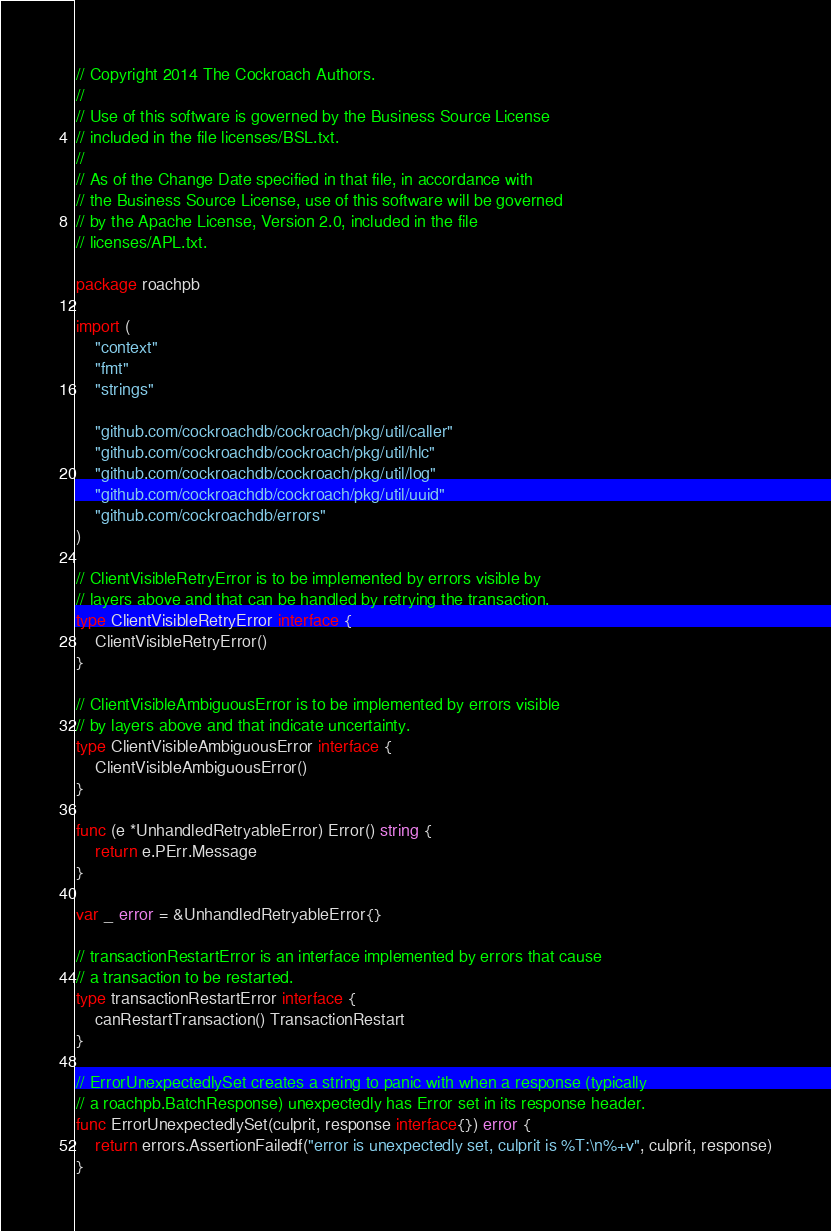<code> <loc_0><loc_0><loc_500><loc_500><_Go_>// Copyright 2014 The Cockroach Authors.
//
// Use of this software is governed by the Business Source License
// included in the file licenses/BSL.txt.
//
// As of the Change Date specified in that file, in accordance with
// the Business Source License, use of this software will be governed
// by the Apache License, Version 2.0, included in the file
// licenses/APL.txt.

package roachpb

import (
	"context"
	"fmt"
	"strings"

	"github.com/cockroachdb/cockroach/pkg/util/caller"
	"github.com/cockroachdb/cockroach/pkg/util/hlc"
	"github.com/cockroachdb/cockroach/pkg/util/log"
	"github.com/cockroachdb/cockroach/pkg/util/uuid"
	"github.com/cockroachdb/errors"
)

// ClientVisibleRetryError is to be implemented by errors visible by
// layers above and that can be handled by retrying the transaction.
type ClientVisibleRetryError interface {
	ClientVisibleRetryError()
}

// ClientVisibleAmbiguousError is to be implemented by errors visible
// by layers above and that indicate uncertainty.
type ClientVisibleAmbiguousError interface {
	ClientVisibleAmbiguousError()
}

func (e *UnhandledRetryableError) Error() string {
	return e.PErr.Message
}

var _ error = &UnhandledRetryableError{}

// transactionRestartError is an interface implemented by errors that cause
// a transaction to be restarted.
type transactionRestartError interface {
	canRestartTransaction() TransactionRestart
}

// ErrorUnexpectedlySet creates a string to panic with when a response (typically
// a roachpb.BatchResponse) unexpectedly has Error set in its response header.
func ErrorUnexpectedlySet(culprit, response interface{}) error {
	return errors.AssertionFailedf("error is unexpectedly set, culprit is %T:\n%+v", culprit, response)
}
</code> 